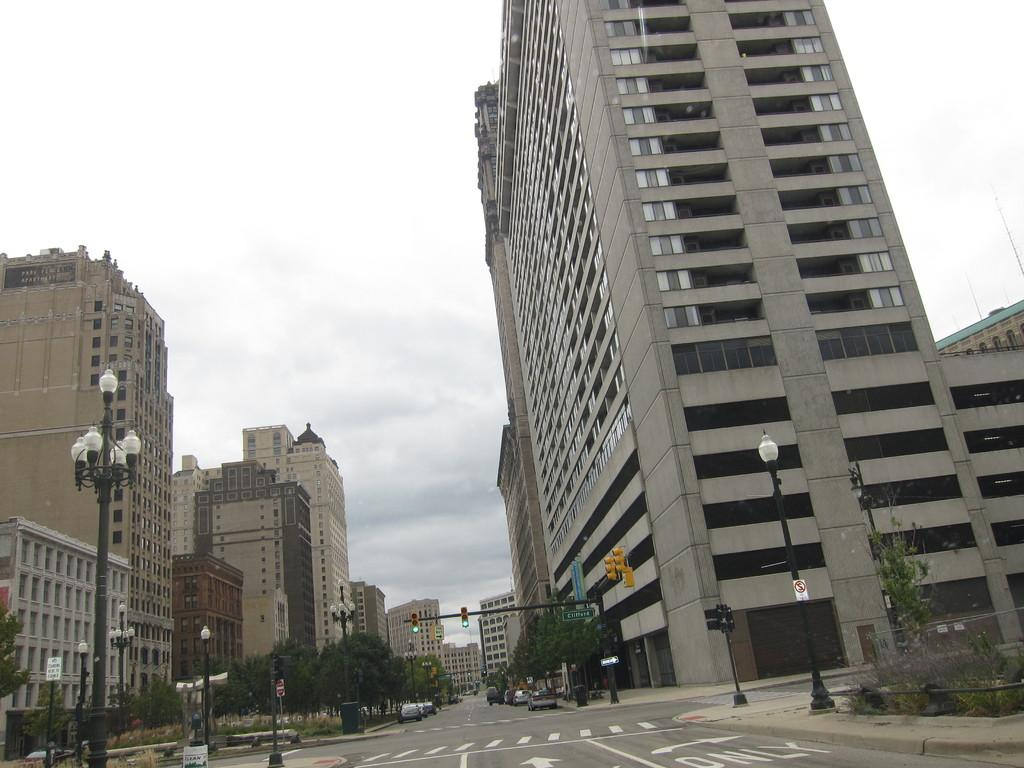What type of structures can be seen in the image? There are buildings in the image. What type of lighting is present in the image? There are street lamps in the image. What type of traffic control is present in the image? There are traffic signals in the image. What type of vegetation is present in the image? There are trees in the image. What type of vehicles are present in the image? There are cars in the image. What part of the natural environment is visible in the image? The sky is visible in the image. What type of weather can be inferred from the image? The presence of clouds in the image suggests that it might be a partly cloudy day. What type of creature can be seen in the stomach of the person in the image? There is no person or stomach visible in the image; it features buildings, street lamps, traffic signals, trees, cars, and a sky with clouds. 